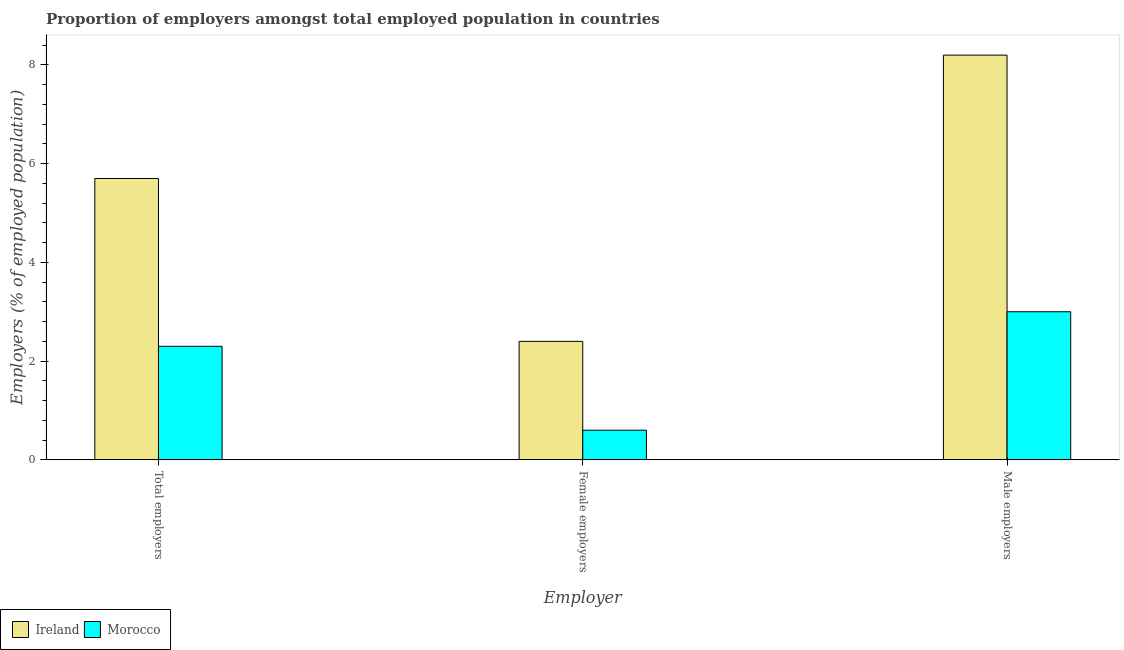How many groups of bars are there?
Your response must be concise. 3. How many bars are there on the 3rd tick from the left?
Keep it short and to the point. 2. What is the label of the 2nd group of bars from the left?
Offer a terse response. Female employers. What is the percentage of total employers in Morocco?
Provide a short and direct response. 2.3. Across all countries, what is the maximum percentage of female employers?
Ensure brevity in your answer.  2.4. Across all countries, what is the minimum percentage of total employers?
Ensure brevity in your answer.  2.3. In which country was the percentage of female employers maximum?
Offer a terse response. Ireland. In which country was the percentage of male employers minimum?
Provide a succinct answer. Morocco. What is the total percentage of male employers in the graph?
Your answer should be very brief. 11.2. What is the difference between the percentage of total employers in Ireland and that in Morocco?
Give a very brief answer. 3.4. What is the difference between the percentage of female employers in Morocco and the percentage of male employers in Ireland?
Your answer should be very brief. -7.6. What is the average percentage of total employers per country?
Keep it short and to the point. 4. What is the difference between the percentage of male employers and percentage of total employers in Morocco?
Provide a short and direct response. 0.7. What is the ratio of the percentage of male employers in Morocco to that in Ireland?
Your response must be concise. 0.37. Is the percentage of female employers in Ireland less than that in Morocco?
Provide a succinct answer. No. What is the difference between the highest and the second highest percentage of female employers?
Ensure brevity in your answer.  1.8. What is the difference between the highest and the lowest percentage of total employers?
Offer a very short reply. 3.4. In how many countries, is the percentage of female employers greater than the average percentage of female employers taken over all countries?
Provide a short and direct response. 1. Is the sum of the percentage of male employers in Ireland and Morocco greater than the maximum percentage of total employers across all countries?
Offer a very short reply. Yes. What does the 2nd bar from the left in Female employers represents?
Keep it short and to the point. Morocco. What does the 2nd bar from the right in Male employers represents?
Offer a very short reply. Ireland. Is it the case that in every country, the sum of the percentage of total employers and percentage of female employers is greater than the percentage of male employers?
Give a very brief answer. No. How many bars are there?
Make the answer very short. 6. Are all the bars in the graph horizontal?
Your answer should be very brief. No. Does the graph contain any zero values?
Keep it short and to the point. No. How many legend labels are there?
Provide a succinct answer. 2. How are the legend labels stacked?
Provide a succinct answer. Horizontal. What is the title of the graph?
Give a very brief answer. Proportion of employers amongst total employed population in countries. Does "West Bank and Gaza" appear as one of the legend labels in the graph?
Keep it short and to the point. No. What is the label or title of the X-axis?
Offer a very short reply. Employer. What is the label or title of the Y-axis?
Your answer should be very brief. Employers (% of employed population). What is the Employers (% of employed population) of Ireland in Total employers?
Make the answer very short. 5.7. What is the Employers (% of employed population) of Morocco in Total employers?
Your answer should be very brief. 2.3. What is the Employers (% of employed population) in Ireland in Female employers?
Keep it short and to the point. 2.4. What is the Employers (% of employed population) of Morocco in Female employers?
Give a very brief answer. 0.6. What is the Employers (% of employed population) in Ireland in Male employers?
Keep it short and to the point. 8.2. What is the Employers (% of employed population) in Morocco in Male employers?
Offer a terse response. 3. Across all Employer, what is the maximum Employers (% of employed population) in Ireland?
Make the answer very short. 8.2. Across all Employer, what is the maximum Employers (% of employed population) in Morocco?
Ensure brevity in your answer.  3. Across all Employer, what is the minimum Employers (% of employed population) in Ireland?
Ensure brevity in your answer.  2.4. Across all Employer, what is the minimum Employers (% of employed population) of Morocco?
Ensure brevity in your answer.  0.6. What is the difference between the Employers (% of employed population) of Ireland in Total employers and that in Female employers?
Provide a short and direct response. 3.3. What is the difference between the Employers (% of employed population) of Morocco in Total employers and that in Female employers?
Your answer should be very brief. 1.7. What is the difference between the Employers (% of employed population) in Morocco in Total employers and that in Male employers?
Keep it short and to the point. -0.7. What is the difference between the Employers (% of employed population) of Ireland in Female employers and that in Male employers?
Offer a terse response. -5.8. What is the difference between the Employers (% of employed population) of Ireland in Total employers and the Employers (% of employed population) of Morocco in Female employers?
Offer a very short reply. 5.1. What is the average Employers (% of employed population) in Ireland per Employer?
Offer a terse response. 5.43. What is the average Employers (% of employed population) of Morocco per Employer?
Your answer should be compact. 1.97. What is the difference between the Employers (% of employed population) in Ireland and Employers (% of employed population) in Morocco in Male employers?
Make the answer very short. 5.2. What is the ratio of the Employers (% of employed population) of Ireland in Total employers to that in Female employers?
Ensure brevity in your answer.  2.38. What is the ratio of the Employers (% of employed population) in Morocco in Total employers to that in Female employers?
Provide a succinct answer. 3.83. What is the ratio of the Employers (% of employed population) in Ireland in Total employers to that in Male employers?
Ensure brevity in your answer.  0.7. What is the ratio of the Employers (% of employed population) in Morocco in Total employers to that in Male employers?
Your answer should be compact. 0.77. What is the ratio of the Employers (% of employed population) of Ireland in Female employers to that in Male employers?
Keep it short and to the point. 0.29. What is the difference between the highest and the second highest Employers (% of employed population) in Ireland?
Offer a very short reply. 2.5. What is the difference between the highest and the second highest Employers (% of employed population) in Morocco?
Offer a very short reply. 0.7. What is the difference between the highest and the lowest Employers (% of employed population) in Ireland?
Your answer should be compact. 5.8. 